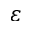<formula> <loc_0><loc_0><loc_500><loc_500>\varepsilon</formula> 